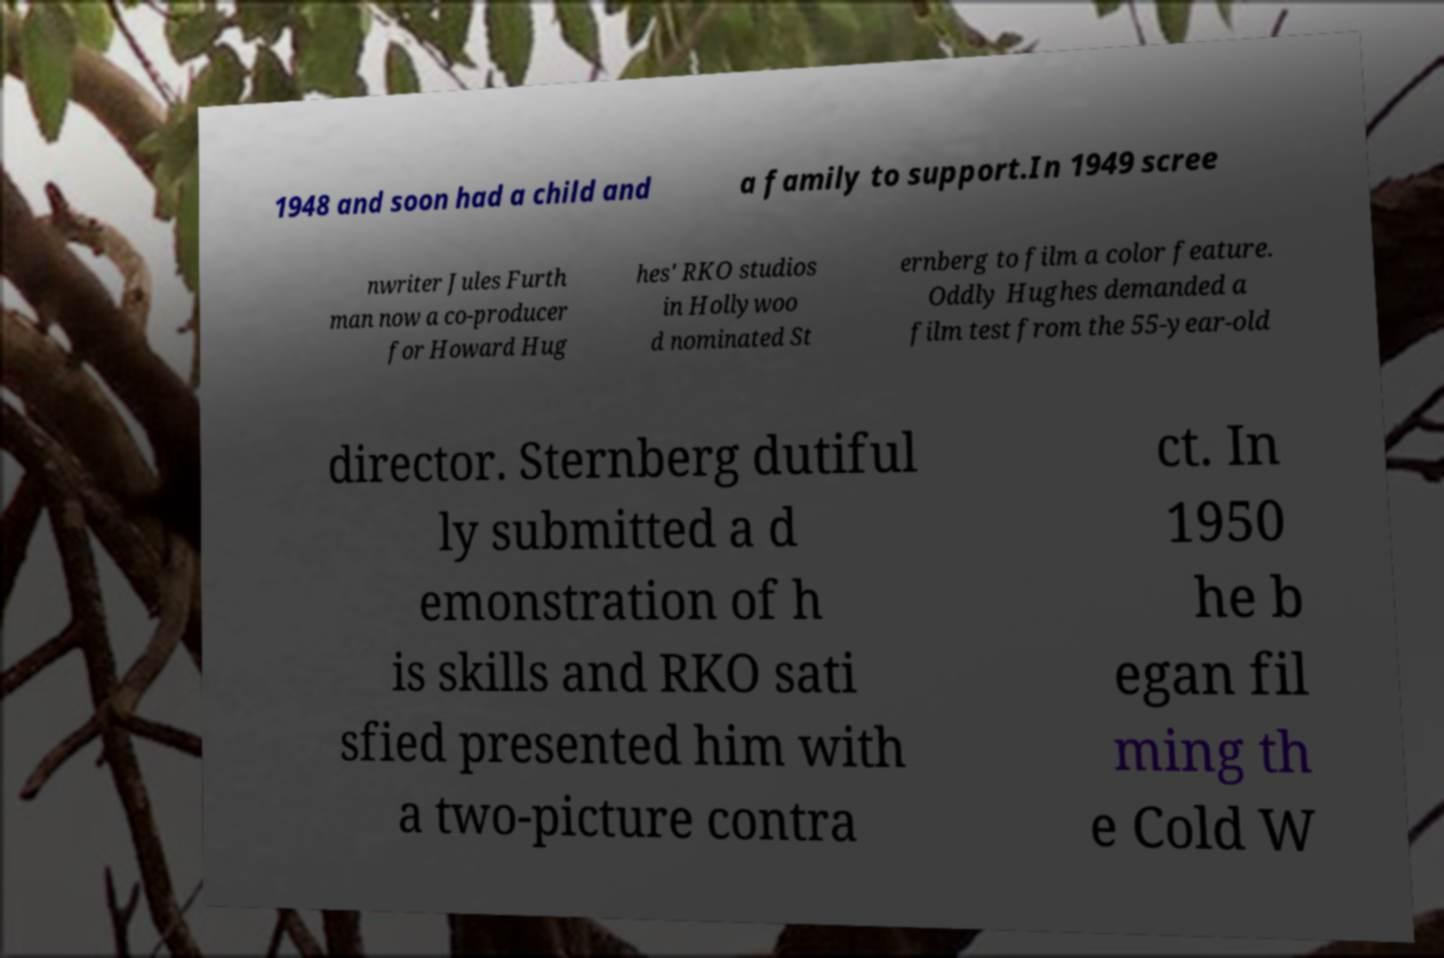I need the written content from this picture converted into text. Can you do that? 1948 and soon had a child and a family to support.In 1949 scree nwriter Jules Furth man now a co-producer for Howard Hug hes' RKO studios in Hollywoo d nominated St ernberg to film a color feature. Oddly Hughes demanded a film test from the 55-year-old director. Sternberg dutiful ly submitted a d emonstration of h is skills and RKO sati sfied presented him with a two-picture contra ct. In 1950 he b egan fil ming th e Cold W 